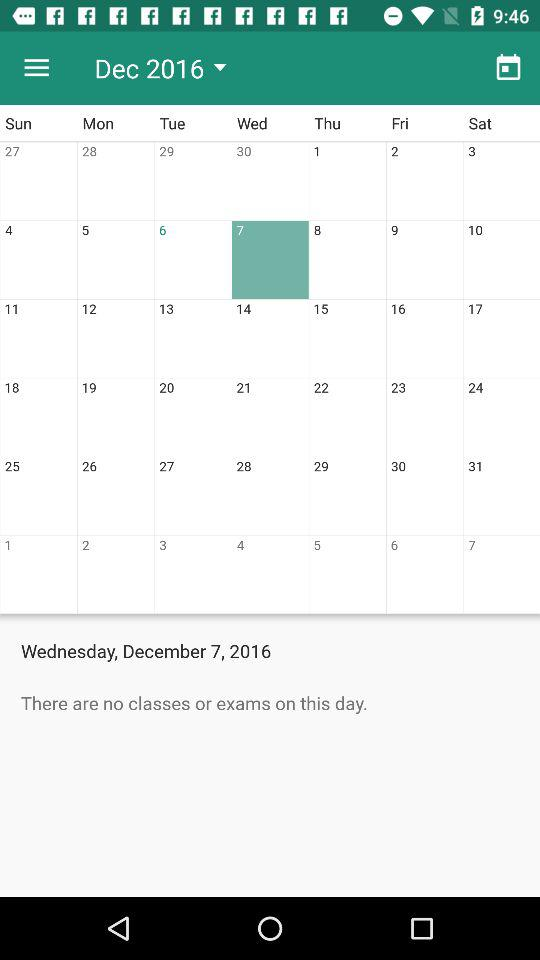Which date is selected? The selected date is Wednesday, December 7, 2016. 